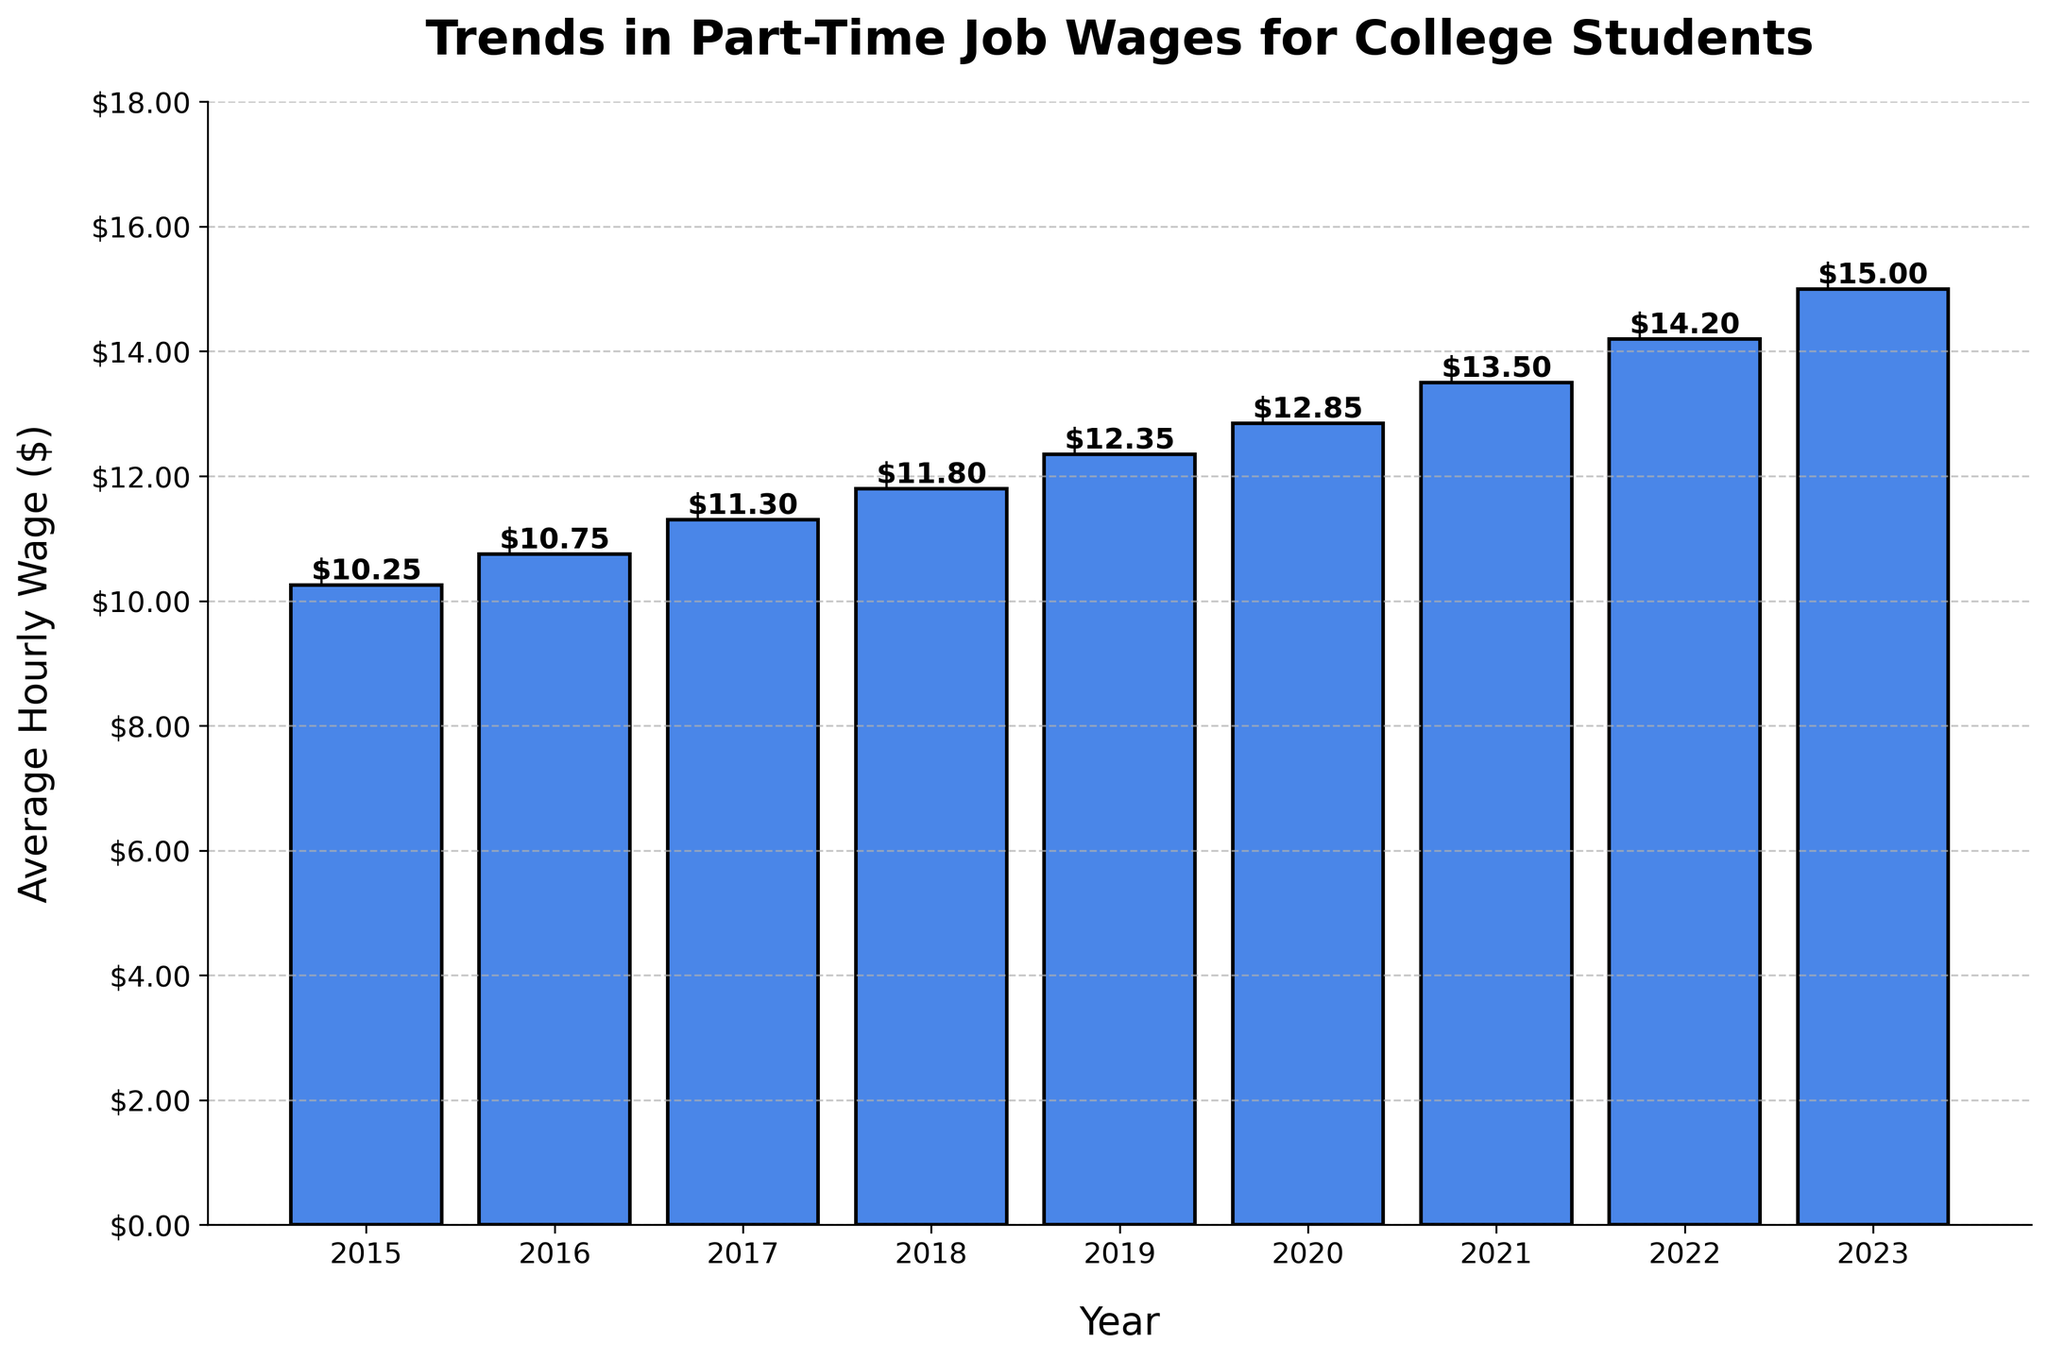What year experienced the highest average hourly wage? The highest average hourly wage can be visually identified by looking at the tallest bar in the chart. The bar corresponding to the year 2023 is the tallest, indicating that it has the highest average hourly wage.
Answer: 2023 What is the difference in average hourly wage between 2020 and 2023? First, look at the heights of the bars for 2020 and 2023. The figure shows $12.85 for 2020 and $15.00 for 2023. Subtract the 2020 wage from the 2023 wage: $15.00 - $12.85 = $2.15.
Answer: $2.15 Which year had a lower average hourly wage: 2016 or 2017? Compare the height of the bars for 2016 and 2017. The bar for 2016 has a smaller height representing a wage of $10.75, while the bar for 2017 represents $11.30. Thus, 2016 had a lower wage.
Answer: 2016 What is the average increase in hourly wage per year from 2015 to 2023? First, calculate the total increase over the years. The wage increased from $10.25 in 2015 to $15.00 in 2023, a total increase of $15.00 - $10.25 = $4.75. There are 8 intervals (years) between 2015 and 2023. The average yearly increase is $4.75 / 8 = $0.59375.
Answer: $0.59 By how much did the average hourly wage increase from 2018 to 2019? Identify the heights of the bars for 2018 and 2019. For 2018, it is $11.80, and for 2019, it is $12.35. Subtract the 2018 wage from the 2019 wage: $12.35 - $11.80 = $0.55.
Answer: $0.55 Was there any year where the average hourly wage remained the same as the previous year? Examine the height of the bars year by year to see if any two consecutive bars are of the same height. Since all the bars have different heights, there was no year where the wage remained the same.
Answer: No What is the sum of the average hourly wages from 2015 to 2017? Add the values for the years 2015, 2016, and 2017. The sums are: $10.25 + $10.75 + $11.30 = $32.30.
Answer: $32.30 